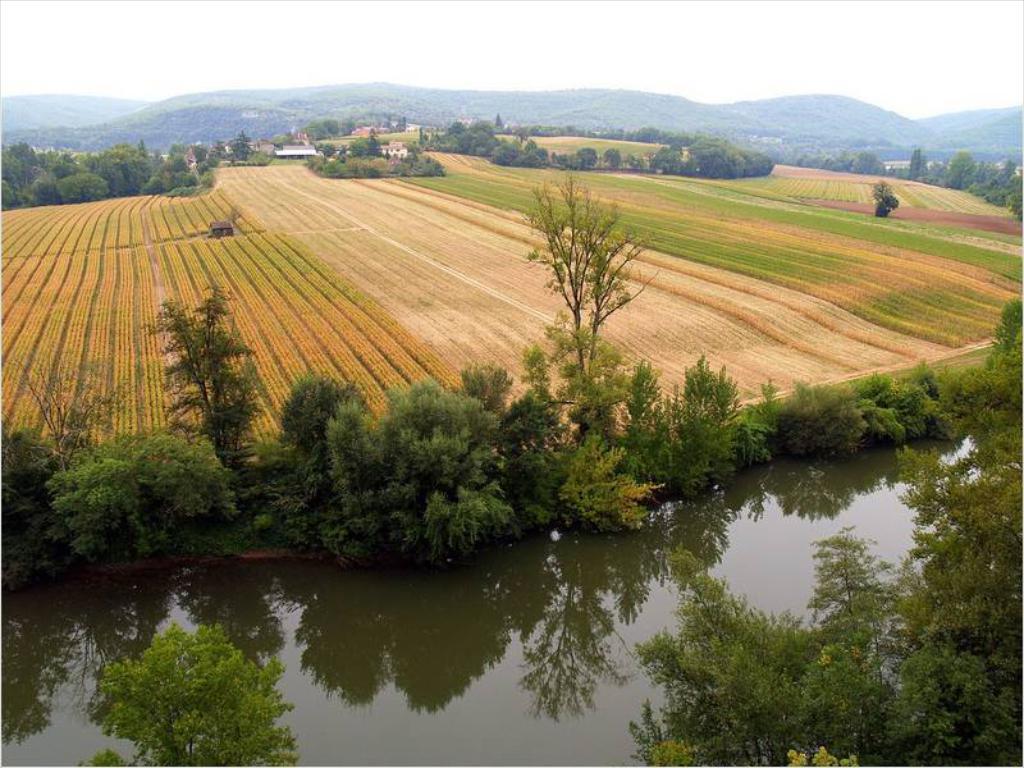In one or two sentences, can you explain what this image depicts? This is the picture of a place where we have a field and around there are some plants, trees, grass and some water to the side. 